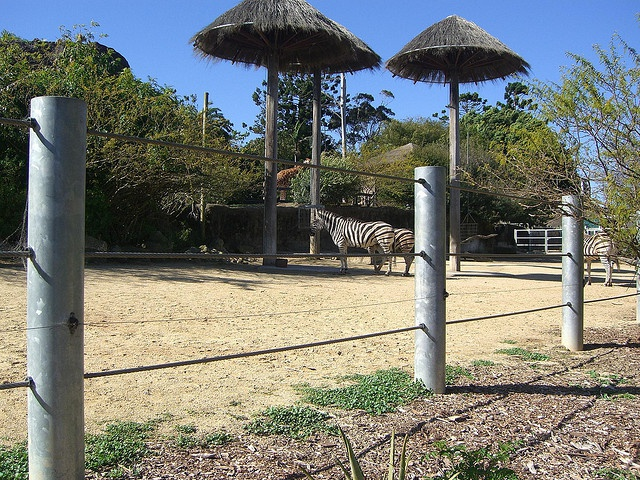Describe the objects in this image and their specific colors. I can see zebra in lightblue, black, gray, ivory, and darkgray tones, zebra in lightblue, ivory, gray, darkgray, and black tones, and zebra in lightblue, black, and gray tones in this image. 